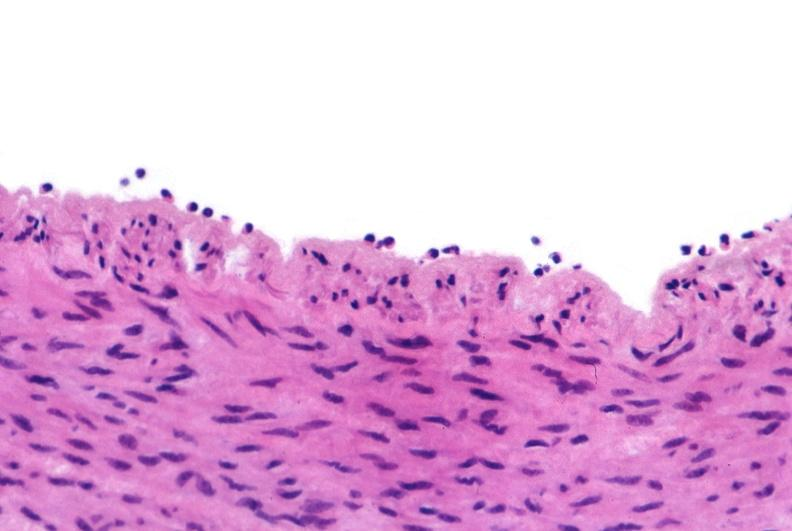what does this image show?
Answer the question using a single word or phrase. Acute inflammation 